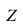<formula> <loc_0><loc_0><loc_500><loc_500>Z</formula> 